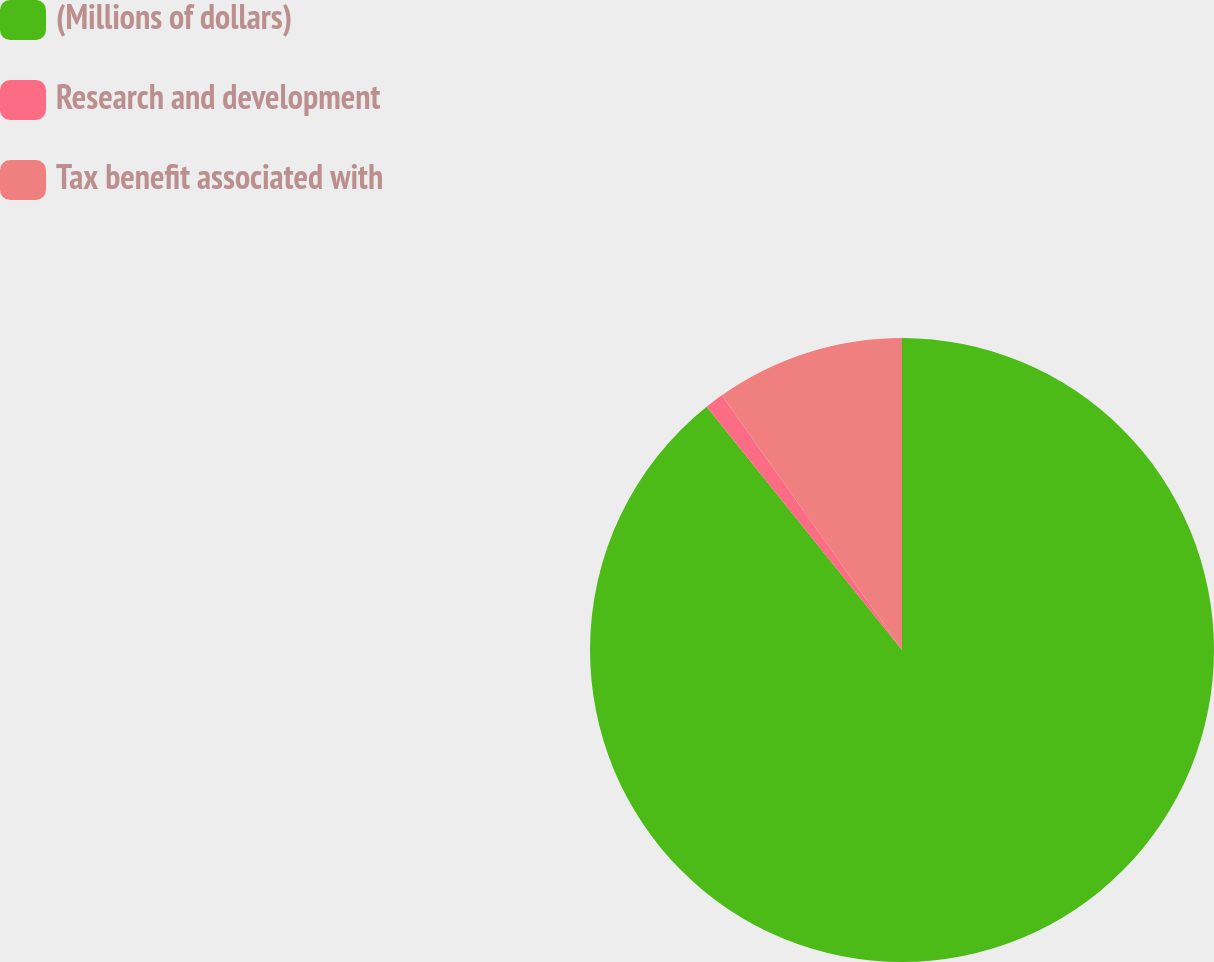Convert chart. <chart><loc_0><loc_0><loc_500><loc_500><pie_chart><fcel>(Millions of dollars)<fcel>Research and development<fcel>Tax benefit associated with<nl><fcel>89.23%<fcel>0.97%<fcel>9.8%<nl></chart> 